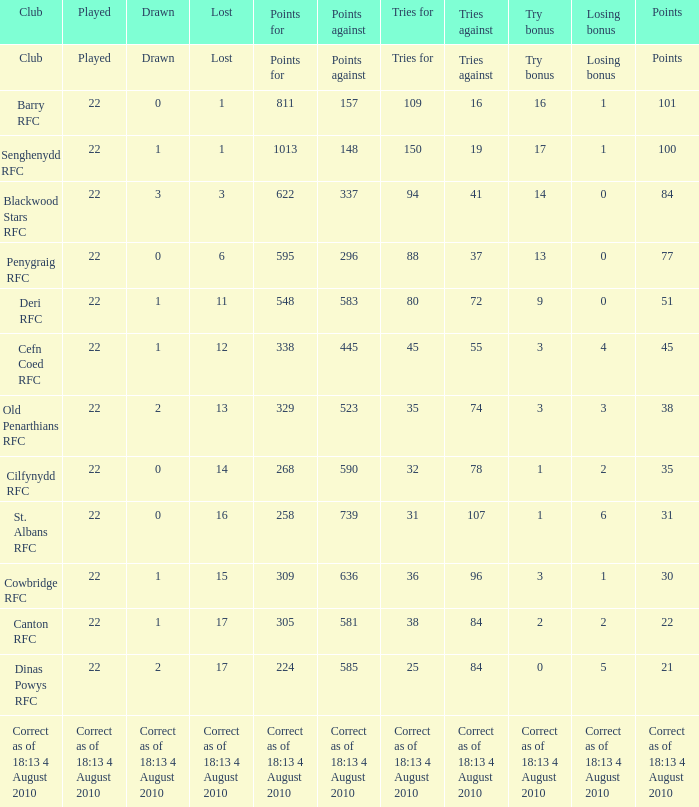What is the losing bonus when drawn was 0, and there were 101 points? 1.0. 